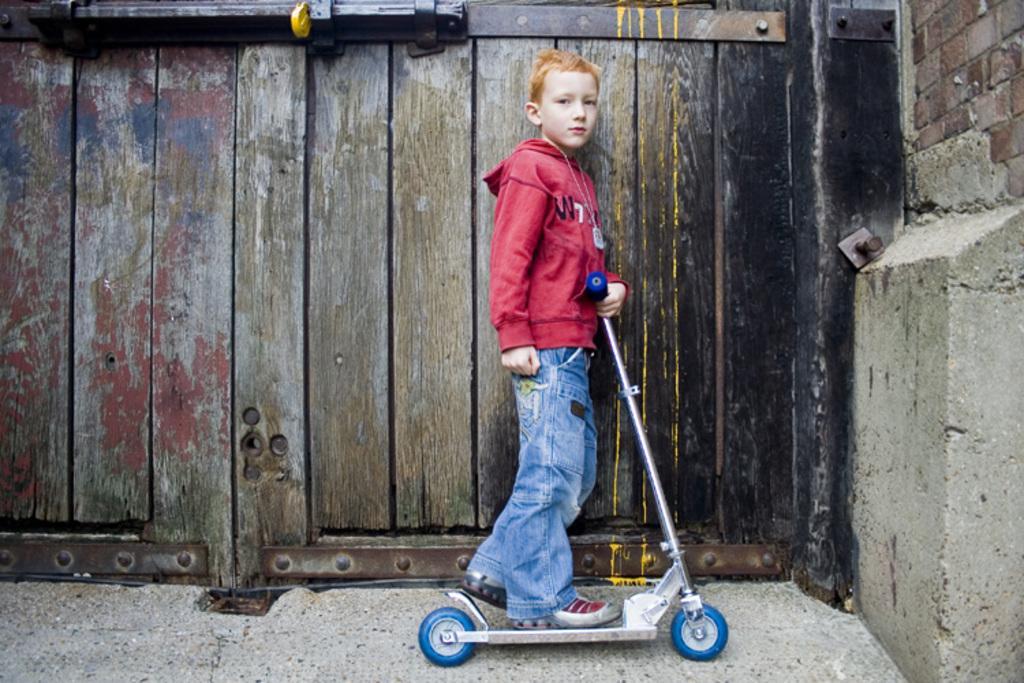Describe this image in one or two sentences. This picture is taken from outside of the door. In this image, in the middle, we can see a boy standing on the vehicle. On the right side, we can see a wall. In the background, we can see a wood door. 